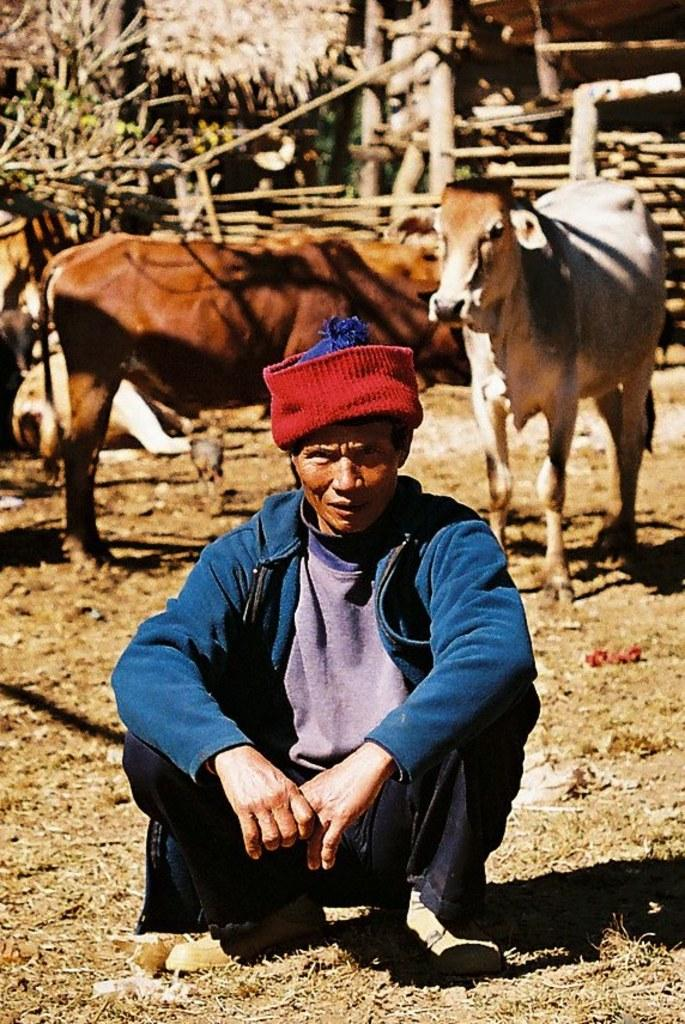What type of animals are present in the image? There are cows of different colors in the image. What type of structures can be seen in the image? There are huts in the image. Can you describe the person in the image? There is a person sitting in the front of the image. What type of dress is the guide wearing in the image? There is no guide present in the image, and therefore no dress to describe. What is the condition of the person's knee in the image? There is no information about the person's knee in the image, so it cannot be determined. 